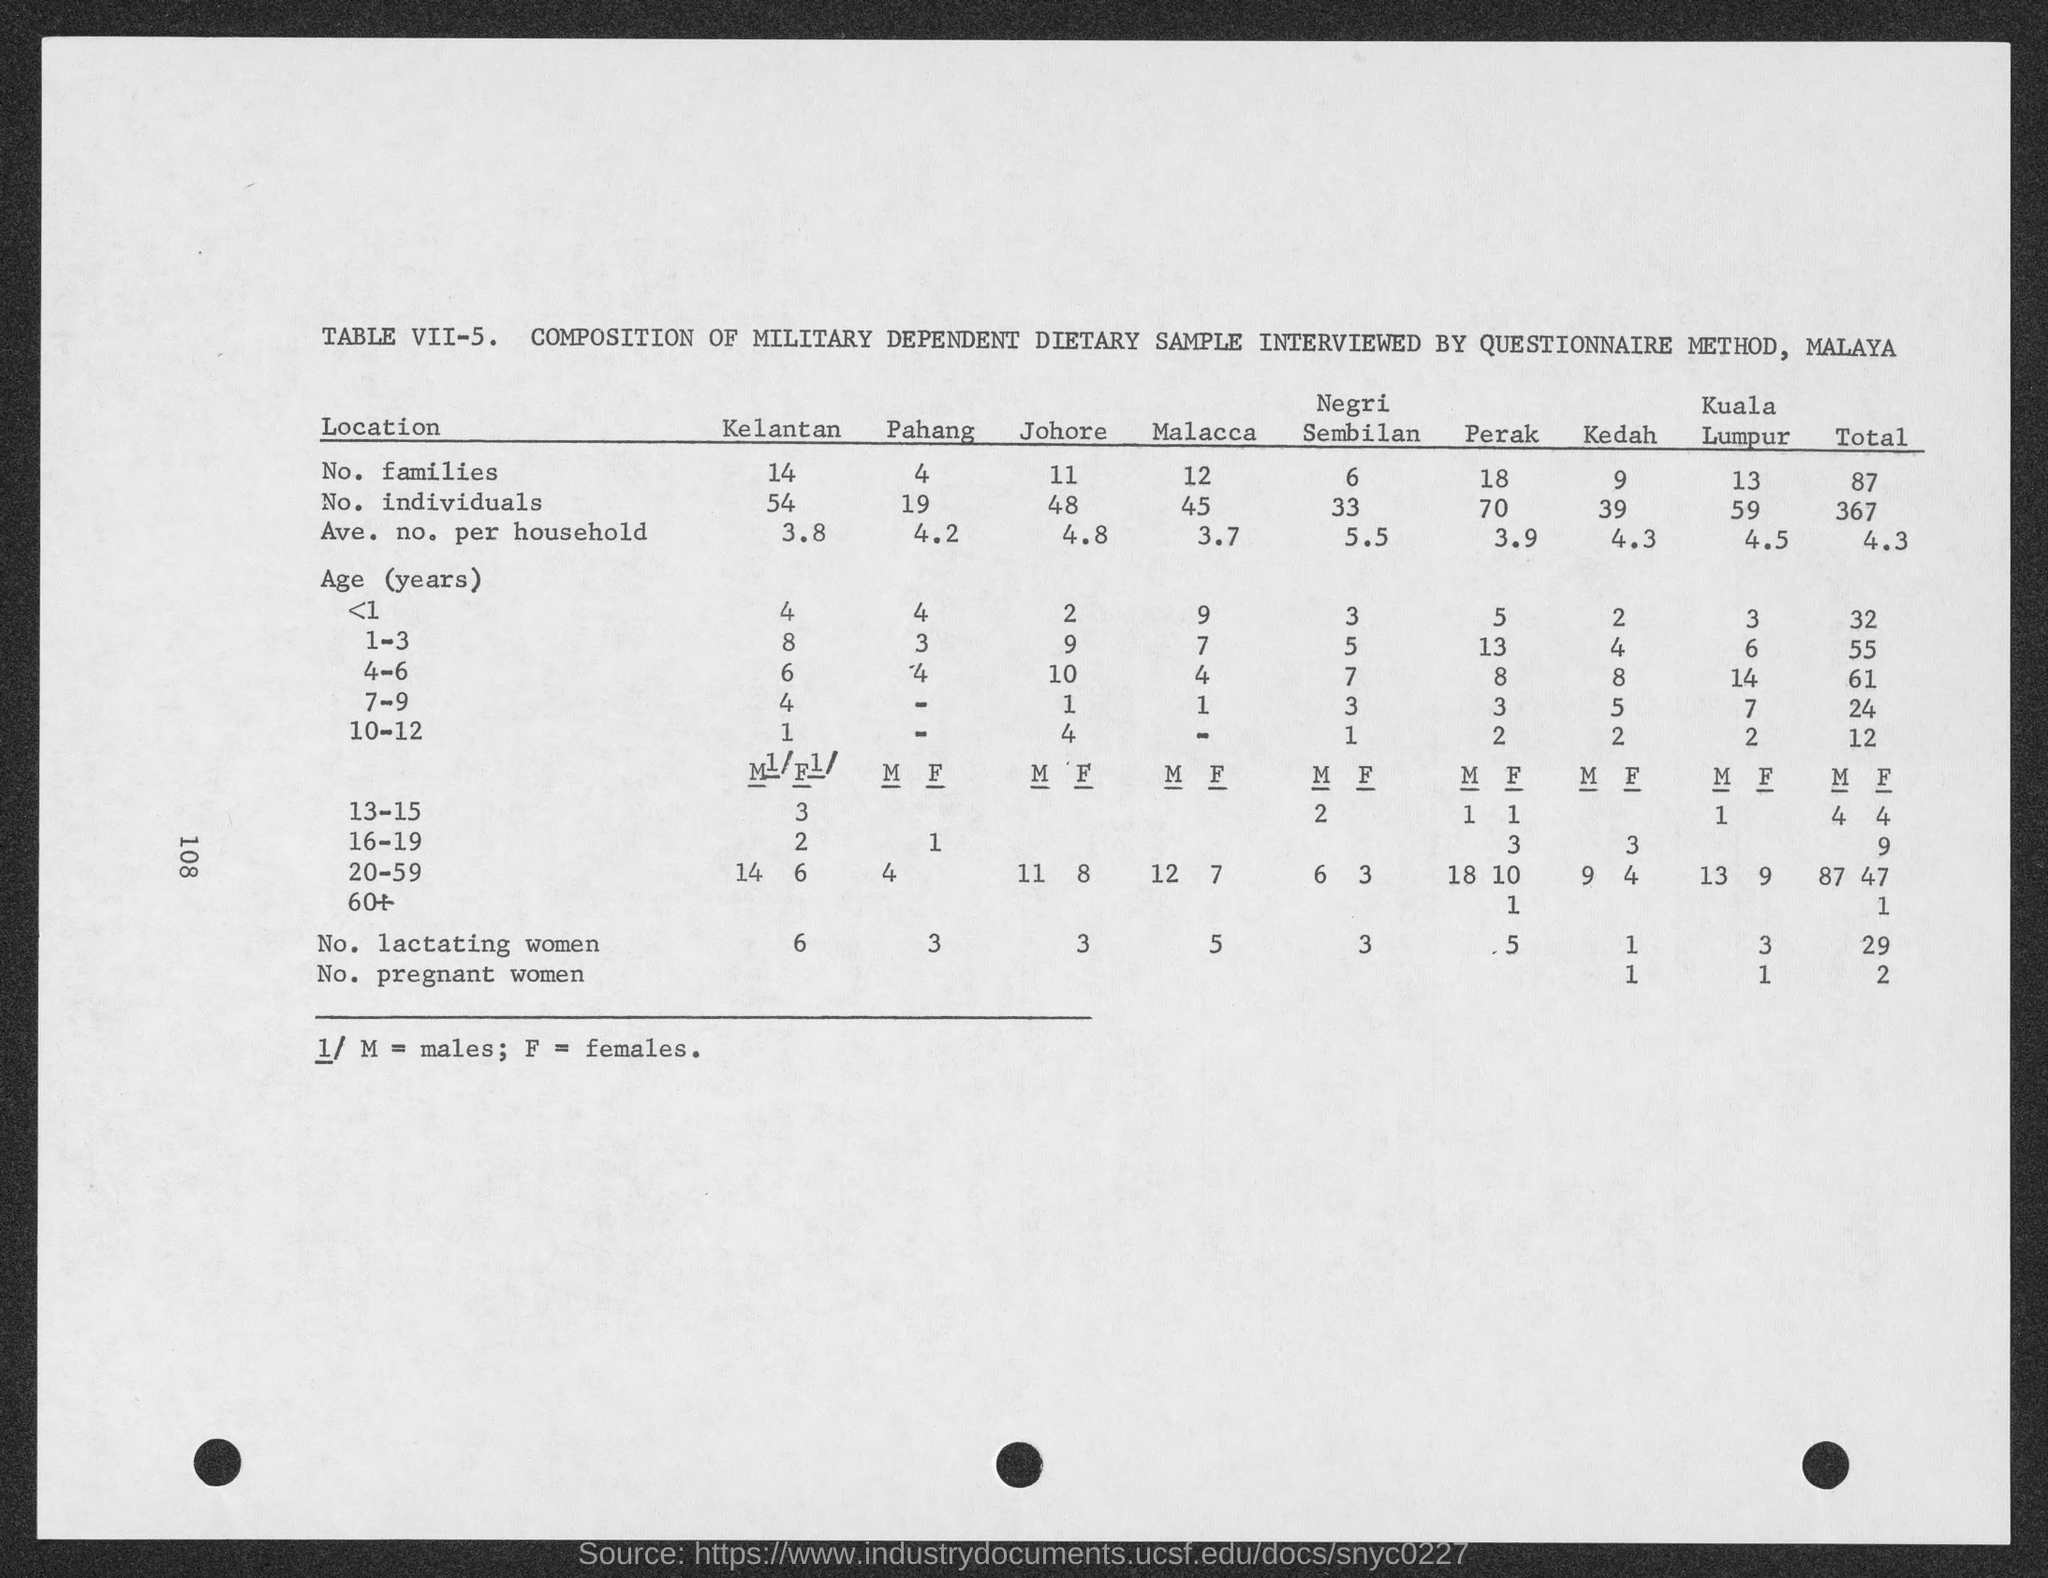Can you tell me more about the document's content? The image shows Table VII-5 titled 'COMPOSITION OF MILITARY DEPENDENT DIETARY SAMPLE INTERVIEWED BY QUESTIONNAIRE METHOD, MALAYA'. It lists data on the number of families, individuals, average number per household, age distribution, and the number of lactating and pregnant women across different locations including Kelantan, Pahang, Johore, Malacca, Negeri Sembilan, Perak, Kedah, and Kuala Lumpur.  What insights can we gather regarding the age distribution from this data? The age distribution data in the table indicates that the sample includes all age groups, from less than 1 year old to over 60 years. The most populous age group is 20-59, which has a total of 87 males and 47 females across the locations. This suggests that the majority of the military dependent population was within the working adult age range. 